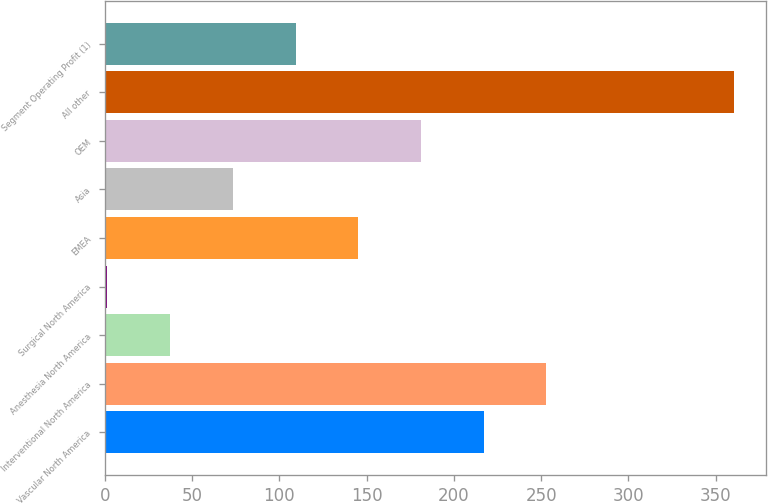Convert chart to OTSL. <chart><loc_0><loc_0><loc_500><loc_500><bar_chart><fcel>Vascular North America<fcel>Interventional North America<fcel>Anesthesia North America<fcel>Surgical North America<fcel>EMEA<fcel>Asia<fcel>OEM<fcel>All other<fcel>Segment Operating Profit (1)<nl><fcel>217.06<fcel>252.97<fcel>37.51<fcel>1.6<fcel>145.24<fcel>73.42<fcel>181.15<fcel>360.7<fcel>109.33<nl></chart> 